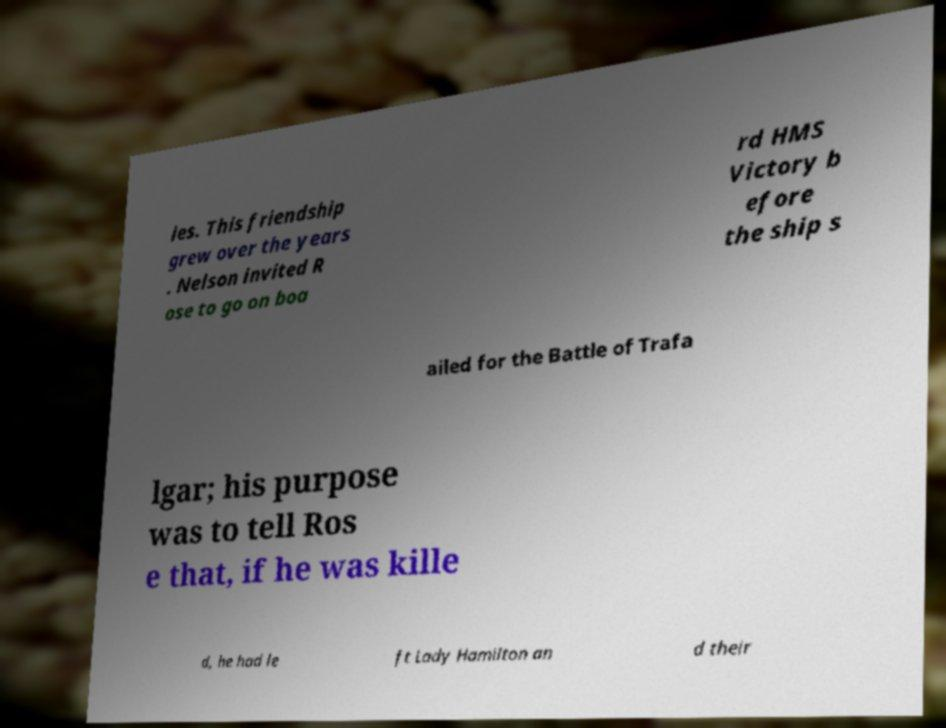Can you read and provide the text displayed in the image?This photo seems to have some interesting text. Can you extract and type it out for me? ies. This friendship grew over the years . Nelson invited R ose to go on boa rd HMS Victory b efore the ship s ailed for the Battle of Trafa lgar; his purpose was to tell Ros e that, if he was kille d, he had le ft Lady Hamilton an d their 